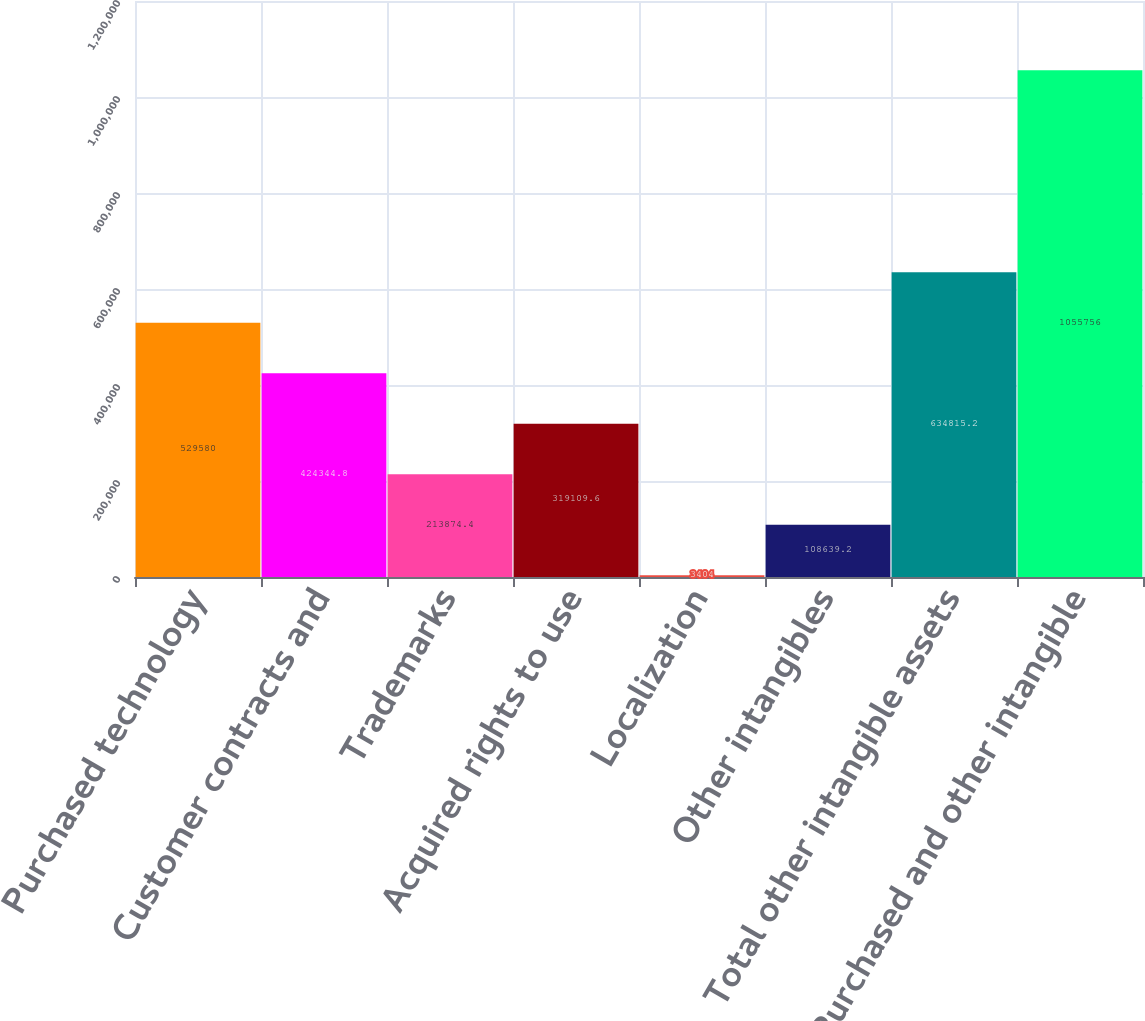Convert chart. <chart><loc_0><loc_0><loc_500><loc_500><bar_chart><fcel>Purchased technology<fcel>Customer contracts and<fcel>Trademarks<fcel>Acquired rights to use<fcel>Localization<fcel>Other intangibles<fcel>Total other intangible assets<fcel>Purchased and other intangible<nl><fcel>529580<fcel>424345<fcel>213874<fcel>319110<fcel>3404<fcel>108639<fcel>634815<fcel>1.05576e+06<nl></chart> 